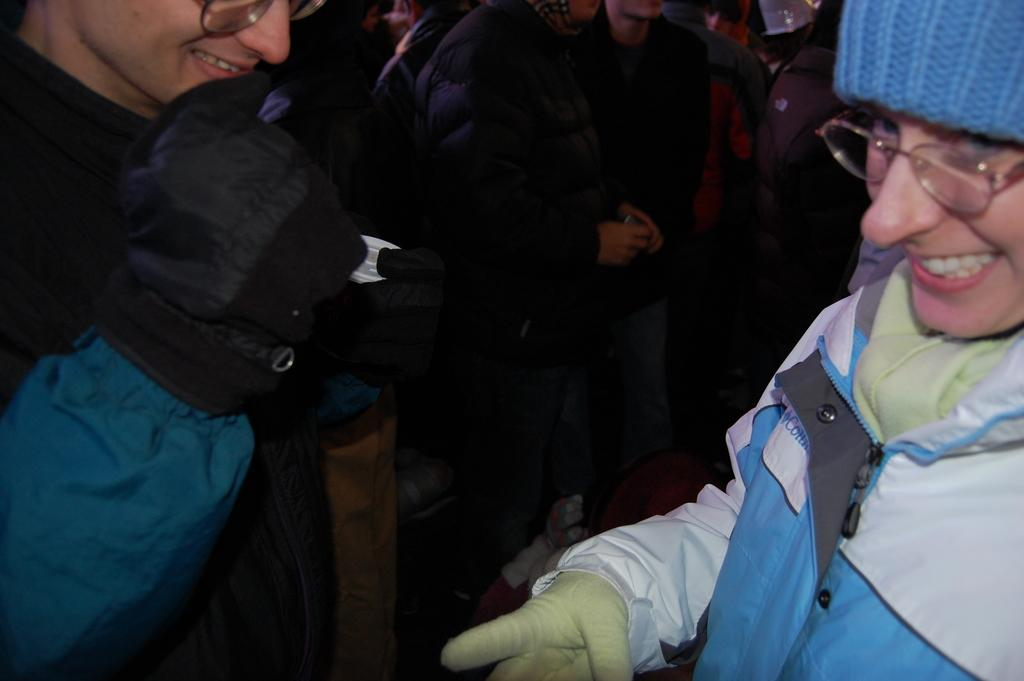How many people are in the foreground of the picture? There are two persons in the foreground of the picture. What are the persons wearing in the image? Both persons are wearing jackets. What expressions do the persons have in the image? The persons have smiles on their faces. Can you describe the people in the background of the image? There are people standing in the background of the image, and they are on the floor. How many fish can be seen swimming near the persons in the image? There are no fish visible in the image; it features two persons wearing jackets and smiling. What type of snails are crawling on the legs of the persons in the image? There are no snails present in the image; the persons are wearing jackets and standing on the floor. 